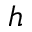<formula> <loc_0><loc_0><loc_500><loc_500>h</formula> 